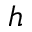<formula> <loc_0><loc_0><loc_500><loc_500>h</formula> 